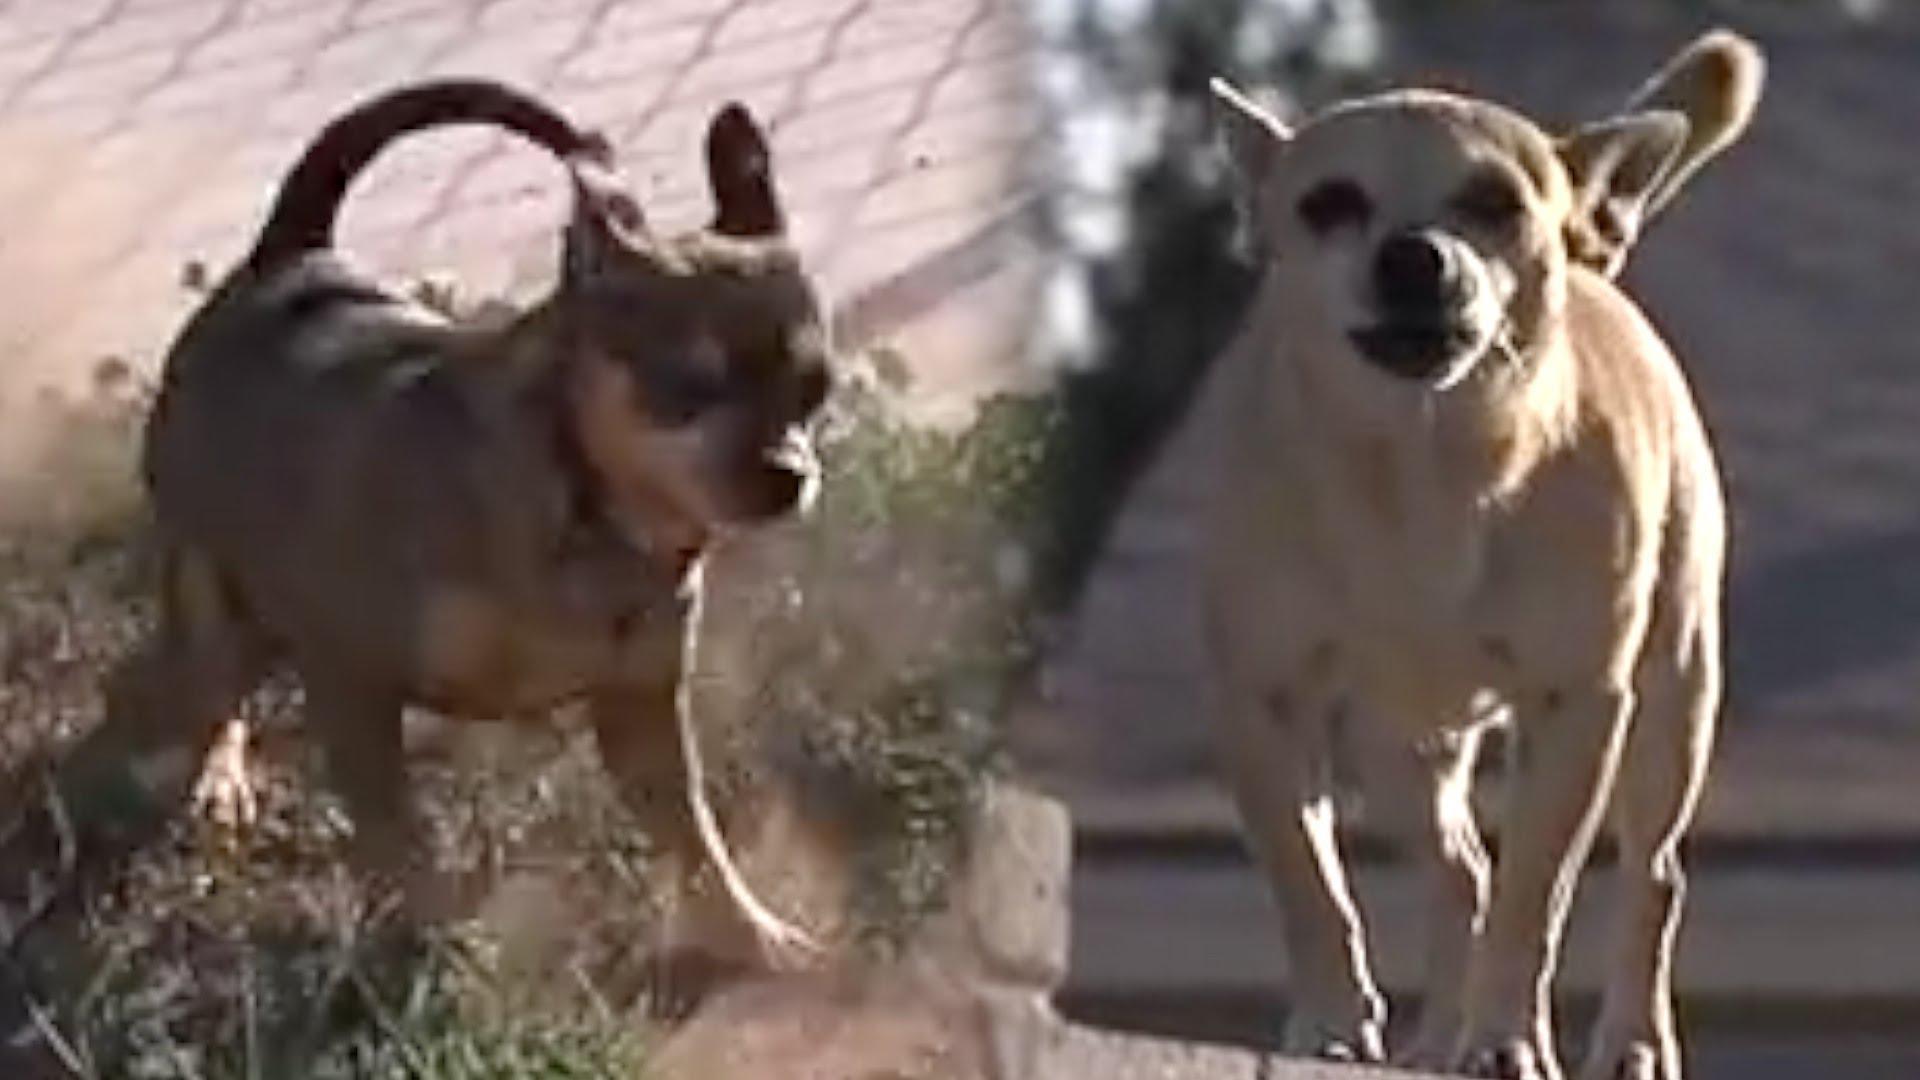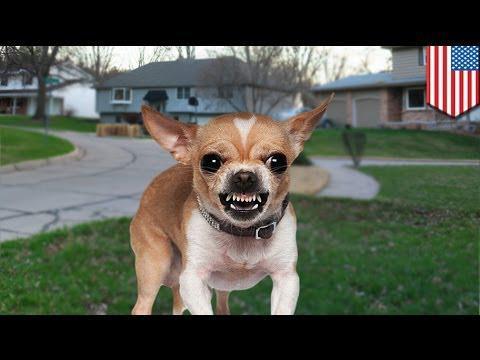The first image is the image on the left, the second image is the image on the right. Examine the images to the left and right. Is the description "One dog in the image on the right is wearing a collar." accurate? Answer yes or no. Yes. The first image is the image on the left, the second image is the image on the right. For the images displayed, is the sentence "An image shows one dog, which is in a grassy area." factually correct? Answer yes or no. Yes. The first image is the image on the left, the second image is the image on the right. For the images shown, is this caption "The images contain at least one row of chihuauas wearing something ornate around their necks and include at least one dog wearing a type of hat." true? Answer yes or no. No. 